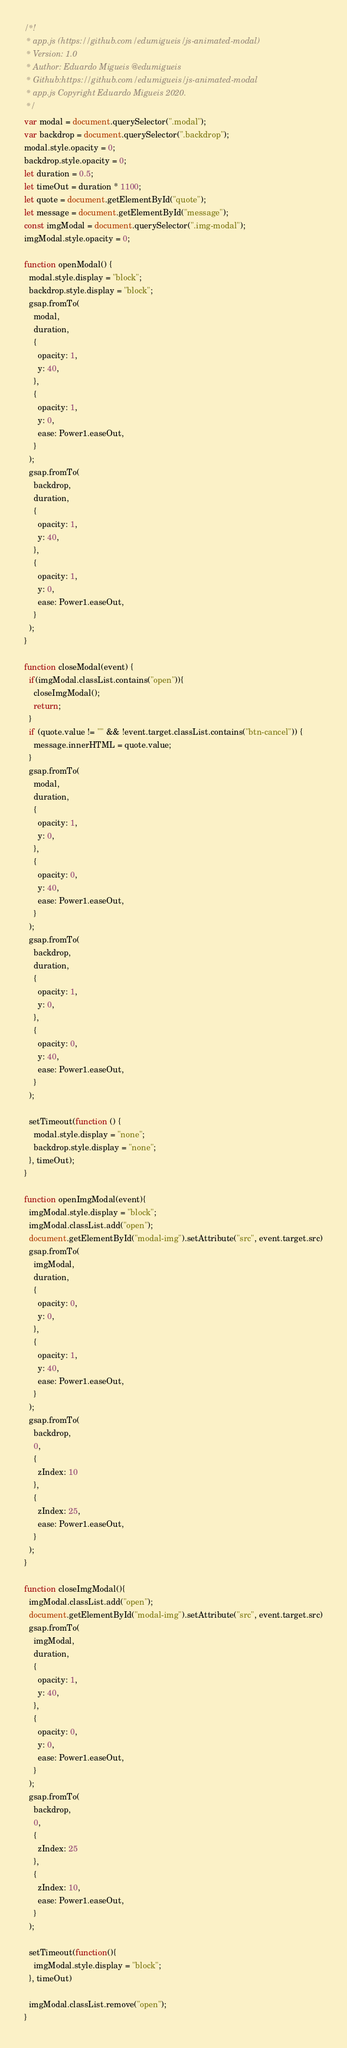Convert code to text. <code><loc_0><loc_0><loc_500><loc_500><_JavaScript_>/*!
 * app.js (https://github.com/edumigueis/js-animated-modal)
 * Version: 1.0
 * Author: Eduardo Migueis @edumigueis
 * Github:https://github.com/edumigueis/js-animated-modal
 * app.js Copyright Eduardo Migueis 2020.
 */
var modal = document.querySelector(".modal");
var backdrop = document.querySelector(".backdrop");
modal.style.opacity = 0;
backdrop.style.opacity = 0;
let duration = 0.5;
let timeOut = duration * 1100;
let quote = document.getElementById("quote");
let message = document.getElementById("message");
const imgModal = document.querySelector(".img-modal");
imgModal.style.opacity = 0;

function openModal() {
  modal.style.display = "block";
  backdrop.style.display = "block";
  gsap.fromTo(
    modal,
    duration,
    {
      opacity: 1,
      y: 40,
    },
    {
      opacity: 1,
      y: 0,
      ease: Power1.easeOut,
    }
  );
  gsap.fromTo(
    backdrop,
    duration,
    {
      opacity: 1,
      y: 40,
    },
    {
      opacity: 1,
      y: 0,
      ease: Power1.easeOut,
    }
  );
}

function closeModal(event) {
  if(imgModal.classList.contains("open")){
    closeImgModal();
    return;
  }
  if (quote.value != "" && !event.target.classList.contains("btn-cancel")) {
    message.innerHTML = quote.value;
  }
  gsap.fromTo(
    modal,
    duration,
    {
      opacity: 1,
      y: 0,
    },
    {
      opacity: 0,
      y: 40,
      ease: Power1.easeOut,
    }
  );
  gsap.fromTo(
    backdrop,
    duration,
    {
      opacity: 1,
      y: 0,
    },
    {
      opacity: 0,
      y: 40,
      ease: Power1.easeOut,
    }
  );

  setTimeout(function () {
    modal.style.display = "none";
    backdrop.style.display = "none";
  }, timeOut);
}

function openImgModal(event){
  imgModal.style.display = "block";
  imgModal.classList.add("open");
  document.getElementById("modal-img").setAttribute("src", event.target.src)
  gsap.fromTo(
    imgModal,
    duration,
    {
      opacity: 0,
      y: 0,
    },
    {
      opacity: 1,
      y: 40,
      ease: Power1.easeOut,
    }
  );
  gsap.fromTo(
    backdrop,
    0,
    {
      zIndex: 10
    },
    {
      zIndex: 25,
      ease: Power1.easeOut,
    }
  );
}

function closeImgModal(){
  imgModal.classList.add("open");
  document.getElementById("modal-img").setAttribute("src", event.target.src)
  gsap.fromTo(
    imgModal,
    duration,
    {
      opacity: 1,
      y: 40,
    },
    {
      opacity: 0,
      y: 0,
      ease: Power1.easeOut,
    }
  );
  gsap.fromTo(
    backdrop,
    0,
    {
      zIndex: 25
    },
    {
      zIndex: 10,
      ease: Power1.easeOut,
    }
  );

  setTimeout(function(){
    imgModal.style.display = "block";
  }, timeOut)

  imgModal.classList.remove("open");
}</code> 